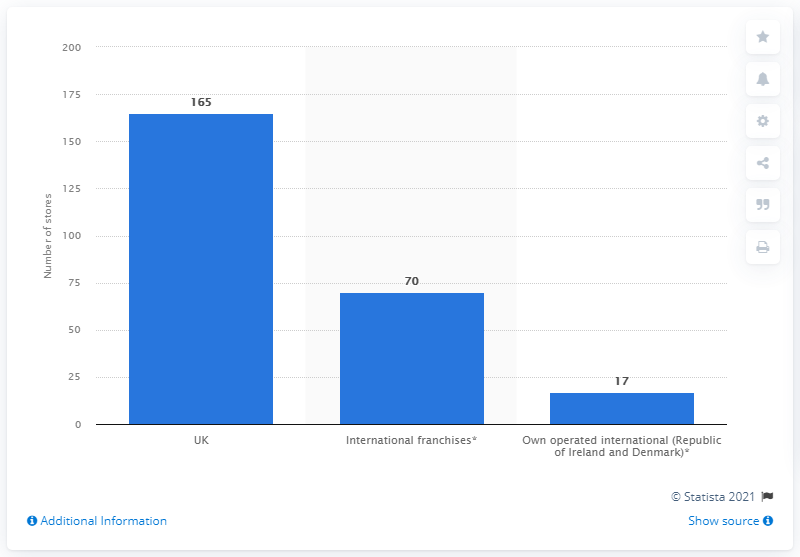Specify some key components in this picture. As of 2021, Debenhams had a total of 165 stores operating in the United Kingdom. 